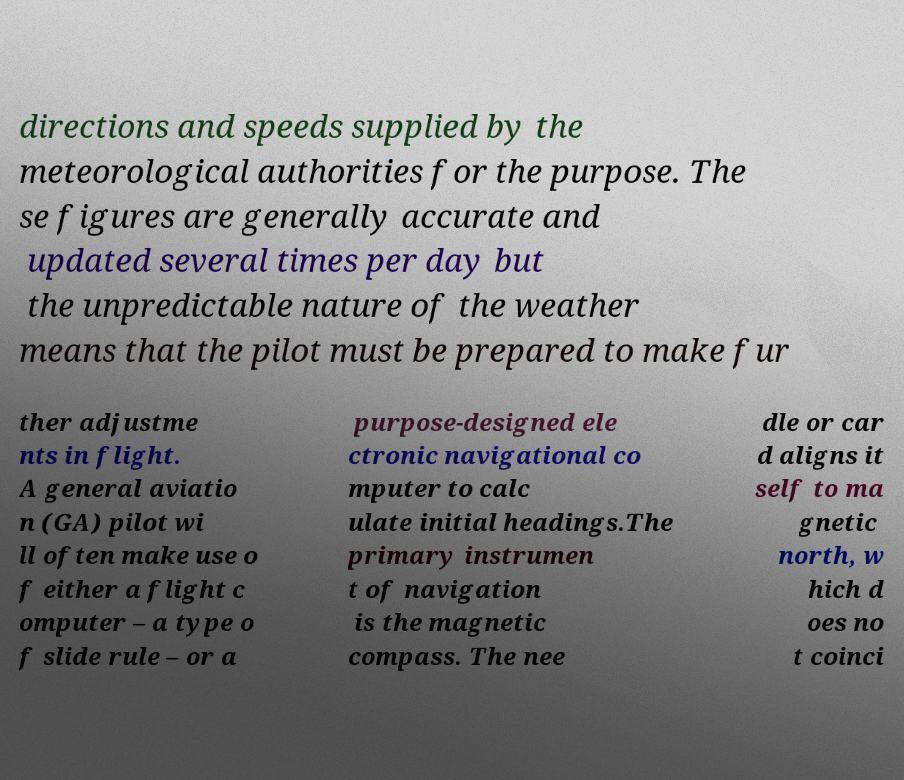I need the written content from this picture converted into text. Can you do that? directions and speeds supplied by the meteorological authorities for the purpose. The se figures are generally accurate and updated several times per day but the unpredictable nature of the weather means that the pilot must be prepared to make fur ther adjustme nts in flight. A general aviatio n (GA) pilot wi ll often make use o f either a flight c omputer – a type o f slide rule – or a purpose-designed ele ctronic navigational co mputer to calc ulate initial headings.The primary instrumen t of navigation is the magnetic compass. The nee dle or car d aligns it self to ma gnetic north, w hich d oes no t coinci 